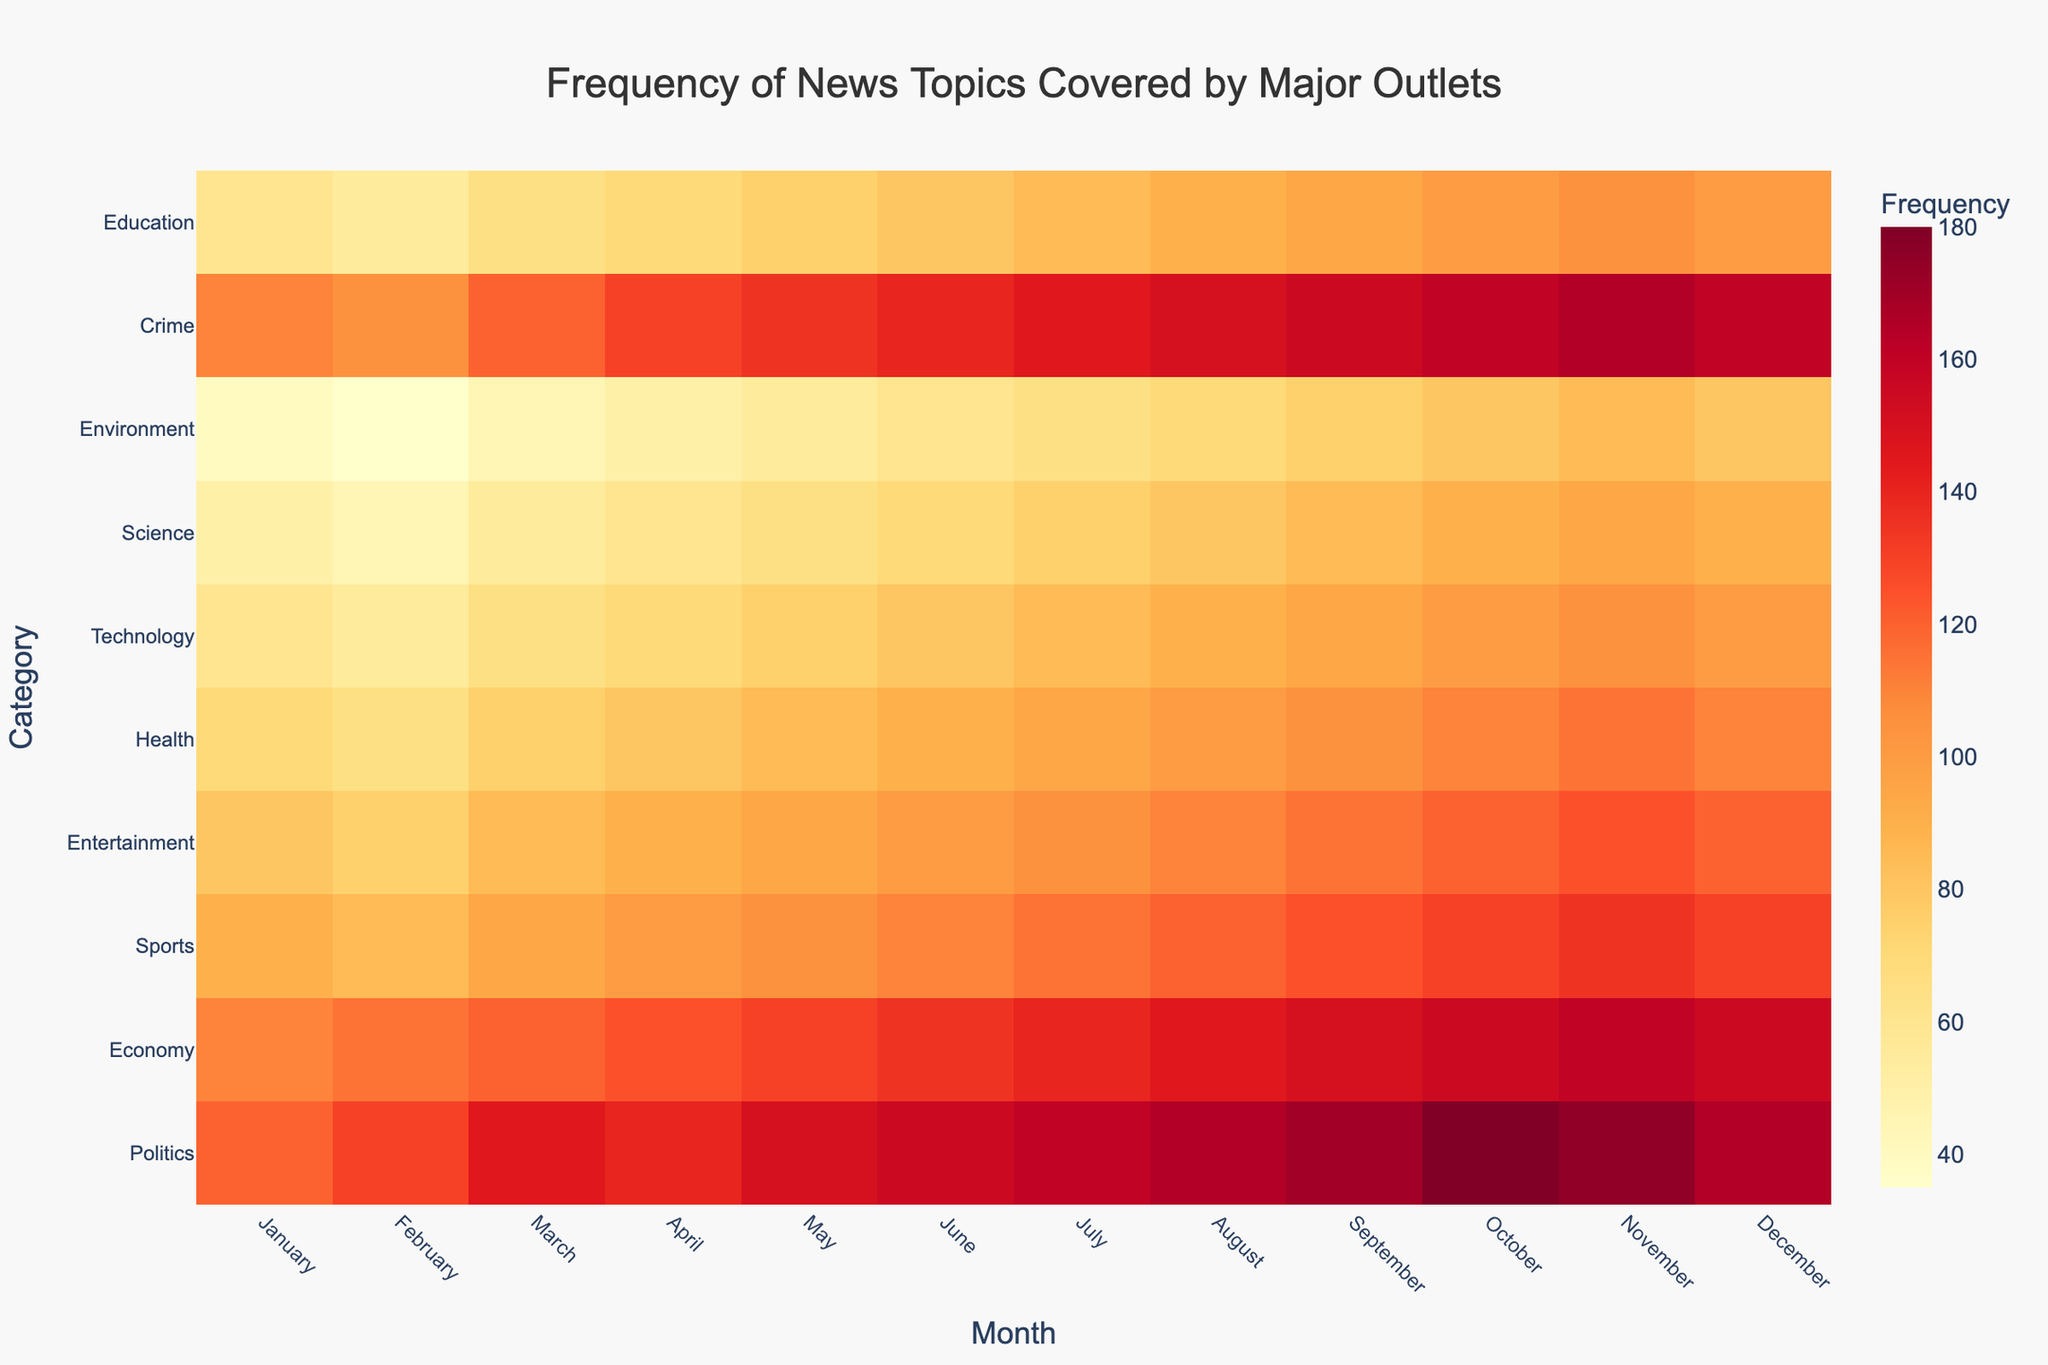What is the frequency of "Politics" news in July? Look at the "Politics" row and locate the column for July.
Answer: 160 Which topic has the highest frequency in December? Check all the values under the December column and find the highest value.
Answer: Politics How does the frequency of "Crime" coverage in March compare to that in September? Locate the "Crime" row and compare the values for March and September.
Answer: September has a higher frequency (155 vs. 120) Which month has the lowest frequency of "Technology" coverage? Find the minimum value in the "Technology" row and note the corresponding month.
Answer: February Is the frequency of "Science" coverage higher in May or October? Check the values for "Science" in May and October and compare them.
Answer: October (90 vs. 65) What is the average frequency of "Economy" news over the year? Add up all the monthly frequencies for the "Economy" and divide by 12.
Answer: (110 + 115 + 120 + 125 + 130 + 135 + 140 + 145 + 150 + 155 + 160 + 155) / 12 = 136.67 By how much did the frequency of "Health" articles increase from January to December? Find the difference between the values for "Health" in January and December.
Answer: 40 (110 - 70) In which month is "Sports" coverage the lowest? Find the minimum value in the "Sports" row and note the corresponding month.
Answer: February Which category experienced the greatest increase in frequency from January to December? Calculate the difference in frequency from January to December for each category and identify the largest.
Answer: Politics (45) What's the sum frequency of "Environment" coverage in the first quarter (January to March)? Add up the values for "Environment" in January, February, and March.
Answer: 120 (40 + 35 + 45) 